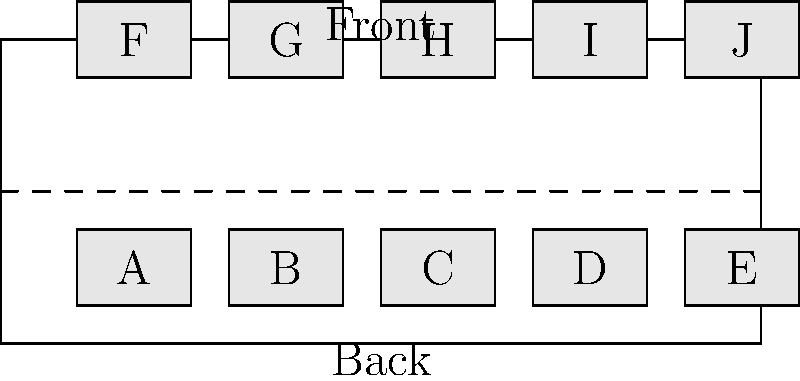A train car has 10 seats arranged as shown in the floor plan above. The train company wants to implement a new seating policy to reduce congestion during boarding. They decide to fill seats from front to back, alternating between sides. What is the correct order in which passengers should be seated to minimize aisle congestion? To minimize aisle congestion, we should fill seats from front to back, alternating between sides. This approach reduces the need for passengers to squeeze past each other in the aisle. Let's determine the seating order step-by-step:

1. Start with the front-most seat on one side: A
2. Move to the opposite side at the same level: F
3. Move back one row on the same side as the previous seat: G
4. Cross to the opposite side at the same level: B
5. Continue this pattern:
   - C (back one, same side as A)
   - H (opposite side, same level as C)
   - I (back one, same side as H)
   - D (opposite side, same level as I)
   - E (back one, same side as D)
   - J (last remaining seat)

This seating order ensures that passengers fill the train car from front to back while alternating sides, which helps to distribute people evenly and reduce congestion in the aisle during the boarding process.
Answer: A, F, G, B, C, H, I, D, E, J 